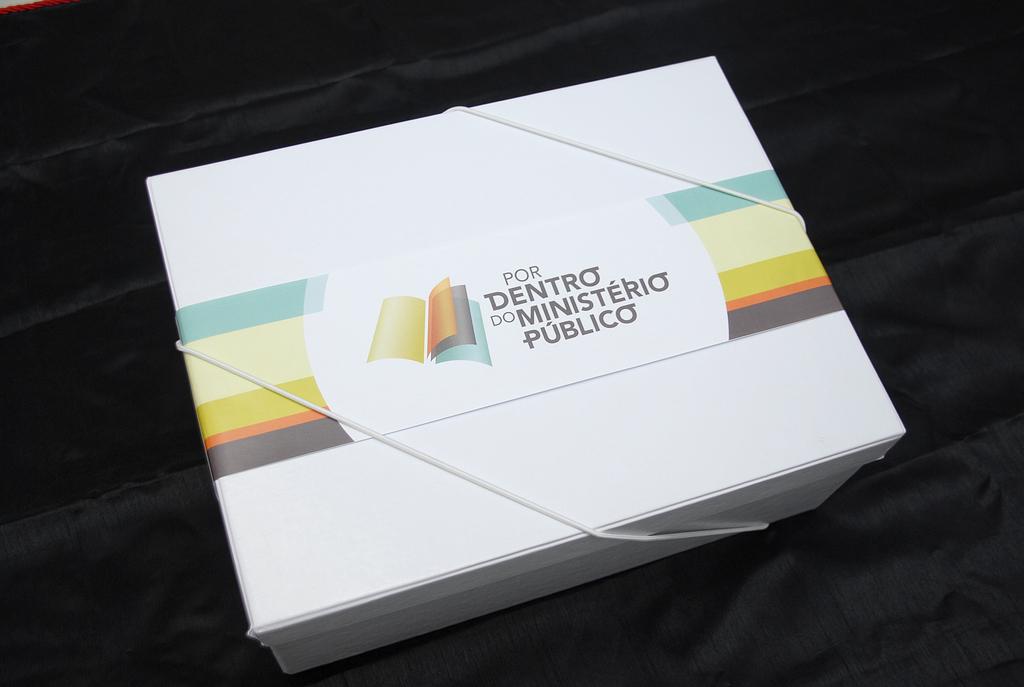What's on the box?
Your answer should be compact. Por dentro do ministerio publico. What color is the words on the box?
Offer a terse response. Answering does not require reading text in the image. 